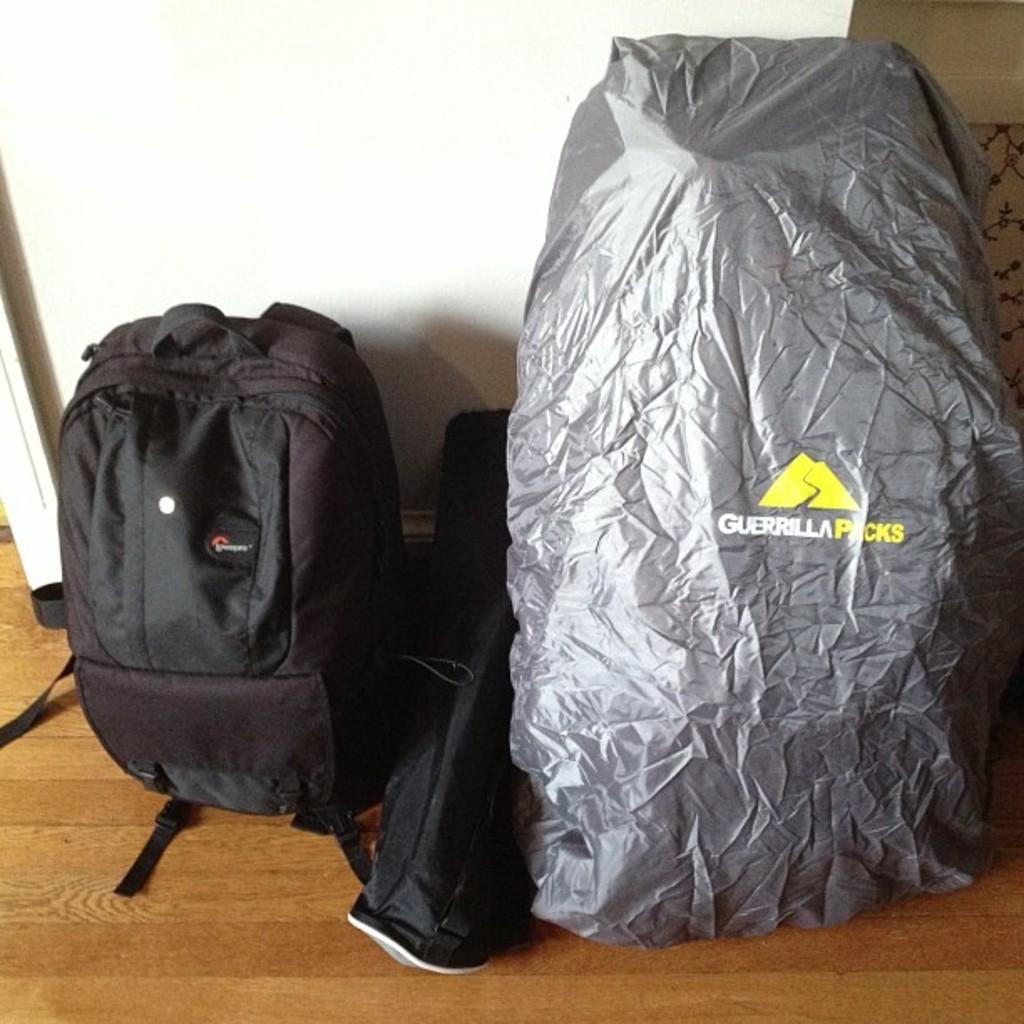In one or two sentences, can you explain what this image depicts? There is a black bag and another gray color cover is on the floor. In the background there is a wall. 